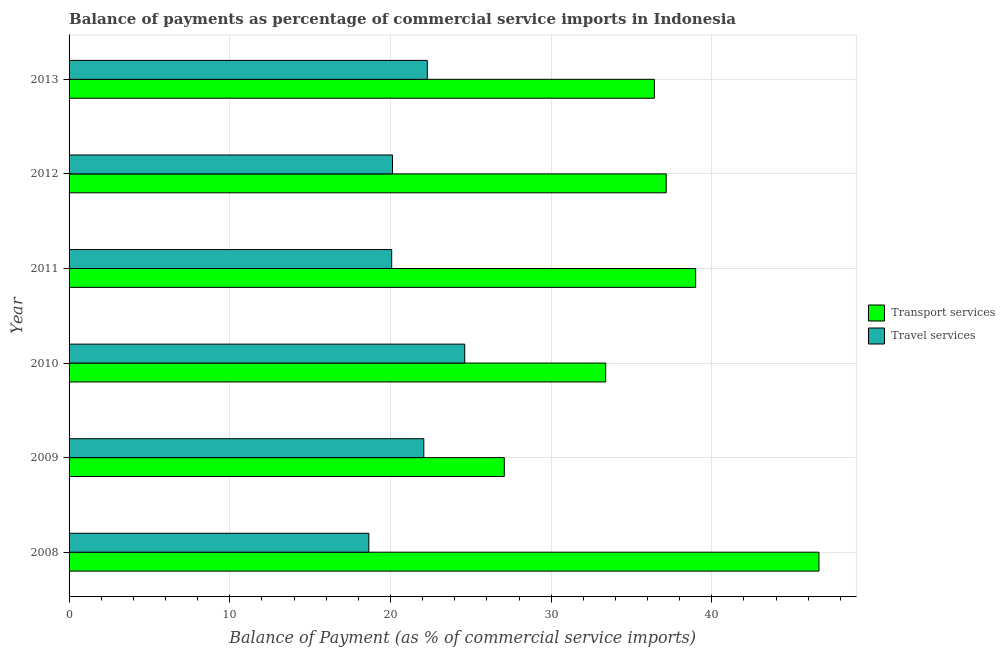In how many cases, is the number of bars for a given year not equal to the number of legend labels?
Keep it short and to the point. 0. What is the balance of payments of transport services in 2010?
Offer a terse response. 33.39. Across all years, what is the maximum balance of payments of transport services?
Ensure brevity in your answer.  46.67. Across all years, what is the minimum balance of payments of travel services?
Your answer should be very brief. 18.65. In which year was the balance of payments of travel services maximum?
Your answer should be compact. 2010. In which year was the balance of payments of travel services minimum?
Your answer should be very brief. 2008. What is the total balance of payments of travel services in the graph?
Give a very brief answer. 127.85. What is the difference between the balance of payments of travel services in 2008 and that in 2012?
Make the answer very short. -1.47. What is the difference between the balance of payments of transport services in 2011 and the balance of payments of travel services in 2009?
Ensure brevity in your answer.  16.92. What is the average balance of payments of transport services per year?
Offer a very short reply. 36.62. In the year 2012, what is the difference between the balance of payments of travel services and balance of payments of transport services?
Offer a very short reply. -17.04. In how many years, is the balance of payments of travel services greater than 14 %?
Give a very brief answer. 6. What is the ratio of the balance of payments of transport services in 2010 to that in 2013?
Your answer should be very brief. 0.92. Is the balance of payments of travel services in 2008 less than that in 2011?
Keep it short and to the point. Yes. What is the difference between the highest and the second highest balance of payments of travel services?
Your answer should be very brief. 2.33. What is the difference between the highest and the lowest balance of payments of travel services?
Your response must be concise. 5.97. Is the sum of the balance of payments of transport services in 2010 and 2011 greater than the maximum balance of payments of travel services across all years?
Offer a terse response. Yes. What does the 1st bar from the top in 2010 represents?
Give a very brief answer. Travel services. What does the 2nd bar from the bottom in 2013 represents?
Provide a succinct answer. Travel services. How many bars are there?
Keep it short and to the point. 12. What is the difference between two consecutive major ticks on the X-axis?
Keep it short and to the point. 10. Are the values on the major ticks of X-axis written in scientific E-notation?
Ensure brevity in your answer.  No. What is the title of the graph?
Your answer should be very brief. Balance of payments as percentage of commercial service imports in Indonesia. What is the label or title of the X-axis?
Your answer should be very brief. Balance of Payment (as % of commercial service imports). What is the Balance of Payment (as % of commercial service imports) in Transport services in 2008?
Provide a succinct answer. 46.67. What is the Balance of Payment (as % of commercial service imports) in Travel services in 2008?
Provide a succinct answer. 18.65. What is the Balance of Payment (as % of commercial service imports) of Transport services in 2009?
Make the answer very short. 27.08. What is the Balance of Payment (as % of commercial service imports) in Travel services in 2009?
Keep it short and to the point. 22.08. What is the Balance of Payment (as % of commercial service imports) of Transport services in 2010?
Provide a succinct answer. 33.39. What is the Balance of Payment (as % of commercial service imports) of Travel services in 2010?
Offer a terse response. 24.62. What is the Balance of Payment (as % of commercial service imports) in Transport services in 2011?
Your response must be concise. 38.99. What is the Balance of Payment (as % of commercial service imports) of Travel services in 2011?
Offer a very short reply. 20.08. What is the Balance of Payment (as % of commercial service imports) in Transport services in 2012?
Your answer should be compact. 37.16. What is the Balance of Payment (as % of commercial service imports) of Travel services in 2012?
Make the answer very short. 20.13. What is the Balance of Payment (as % of commercial service imports) in Transport services in 2013?
Your answer should be compact. 36.42. What is the Balance of Payment (as % of commercial service imports) in Travel services in 2013?
Your answer should be very brief. 22.29. Across all years, what is the maximum Balance of Payment (as % of commercial service imports) of Transport services?
Make the answer very short. 46.67. Across all years, what is the maximum Balance of Payment (as % of commercial service imports) in Travel services?
Your response must be concise. 24.62. Across all years, what is the minimum Balance of Payment (as % of commercial service imports) of Transport services?
Your answer should be compact. 27.08. Across all years, what is the minimum Balance of Payment (as % of commercial service imports) in Travel services?
Give a very brief answer. 18.65. What is the total Balance of Payment (as % of commercial service imports) of Transport services in the graph?
Provide a succinct answer. 219.72. What is the total Balance of Payment (as % of commercial service imports) in Travel services in the graph?
Make the answer very short. 127.85. What is the difference between the Balance of Payment (as % of commercial service imports) in Transport services in 2008 and that in 2009?
Your answer should be compact. 19.58. What is the difference between the Balance of Payment (as % of commercial service imports) of Travel services in 2008 and that in 2009?
Your response must be concise. -3.42. What is the difference between the Balance of Payment (as % of commercial service imports) in Transport services in 2008 and that in 2010?
Give a very brief answer. 13.27. What is the difference between the Balance of Payment (as % of commercial service imports) of Travel services in 2008 and that in 2010?
Keep it short and to the point. -5.97. What is the difference between the Balance of Payment (as % of commercial service imports) in Transport services in 2008 and that in 2011?
Make the answer very short. 7.67. What is the difference between the Balance of Payment (as % of commercial service imports) of Travel services in 2008 and that in 2011?
Ensure brevity in your answer.  -1.42. What is the difference between the Balance of Payment (as % of commercial service imports) in Transport services in 2008 and that in 2012?
Make the answer very short. 9.5. What is the difference between the Balance of Payment (as % of commercial service imports) of Travel services in 2008 and that in 2012?
Your answer should be compact. -1.47. What is the difference between the Balance of Payment (as % of commercial service imports) of Transport services in 2008 and that in 2013?
Ensure brevity in your answer.  10.24. What is the difference between the Balance of Payment (as % of commercial service imports) of Travel services in 2008 and that in 2013?
Offer a very short reply. -3.64. What is the difference between the Balance of Payment (as % of commercial service imports) of Transport services in 2009 and that in 2010?
Your answer should be compact. -6.31. What is the difference between the Balance of Payment (as % of commercial service imports) in Travel services in 2009 and that in 2010?
Your answer should be very brief. -2.55. What is the difference between the Balance of Payment (as % of commercial service imports) of Transport services in 2009 and that in 2011?
Keep it short and to the point. -11.91. What is the difference between the Balance of Payment (as % of commercial service imports) in Travel services in 2009 and that in 2011?
Provide a succinct answer. 2. What is the difference between the Balance of Payment (as % of commercial service imports) of Transport services in 2009 and that in 2012?
Provide a short and direct response. -10.08. What is the difference between the Balance of Payment (as % of commercial service imports) in Travel services in 2009 and that in 2012?
Provide a short and direct response. 1.95. What is the difference between the Balance of Payment (as % of commercial service imports) in Transport services in 2009 and that in 2013?
Ensure brevity in your answer.  -9.34. What is the difference between the Balance of Payment (as % of commercial service imports) in Travel services in 2009 and that in 2013?
Your response must be concise. -0.22. What is the difference between the Balance of Payment (as % of commercial service imports) in Transport services in 2010 and that in 2011?
Provide a short and direct response. -5.6. What is the difference between the Balance of Payment (as % of commercial service imports) in Travel services in 2010 and that in 2011?
Give a very brief answer. 4.54. What is the difference between the Balance of Payment (as % of commercial service imports) in Transport services in 2010 and that in 2012?
Offer a terse response. -3.77. What is the difference between the Balance of Payment (as % of commercial service imports) of Travel services in 2010 and that in 2012?
Offer a terse response. 4.49. What is the difference between the Balance of Payment (as % of commercial service imports) in Transport services in 2010 and that in 2013?
Give a very brief answer. -3.03. What is the difference between the Balance of Payment (as % of commercial service imports) of Travel services in 2010 and that in 2013?
Offer a terse response. 2.33. What is the difference between the Balance of Payment (as % of commercial service imports) of Transport services in 2011 and that in 2012?
Ensure brevity in your answer.  1.83. What is the difference between the Balance of Payment (as % of commercial service imports) in Travel services in 2011 and that in 2012?
Provide a succinct answer. -0.05. What is the difference between the Balance of Payment (as % of commercial service imports) in Transport services in 2011 and that in 2013?
Your answer should be very brief. 2.57. What is the difference between the Balance of Payment (as % of commercial service imports) in Travel services in 2011 and that in 2013?
Make the answer very short. -2.22. What is the difference between the Balance of Payment (as % of commercial service imports) in Transport services in 2012 and that in 2013?
Offer a terse response. 0.74. What is the difference between the Balance of Payment (as % of commercial service imports) of Travel services in 2012 and that in 2013?
Your answer should be very brief. -2.17. What is the difference between the Balance of Payment (as % of commercial service imports) of Transport services in 2008 and the Balance of Payment (as % of commercial service imports) of Travel services in 2009?
Ensure brevity in your answer.  24.59. What is the difference between the Balance of Payment (as % of commercial service imports) of Transport services in 2008 and the Balance of Payment (as % of commercial service imports) of Travel services in 2010?
Offer a terse response. 22.04. What is the difference between the Balance of Payment (as % of commercial service imports) of Transport services in 2008 and the Balance of Payment (as % of commercial service imports) of Travel services in 2011?
Provide a short and direct response. 26.59. What is the difference between the Balance of Payment (as % of commercial service imports) of Transport services in 2008 and the Balance of Payment (as % of commercial service imports) of Travel services in 2012?
Keep it short and to the point. 26.54. What is the difference between the Balance of Payment (as % of commercial service imports) in Transport services in 2008 and the Balance of Payment (as % of commercial service imports) in Travel services in 2013?
Offer a terse response. 24.37. What is the difference between the Balance of Payment (as % of commercial service imports) in Transport services in 2009 and the Balance of Payment (as % of commercial service imports) in Travel services in 2010?
Provide a short and direct response. 2.46. What is the difference between the Balance of Payment (as % of commercial service imports) of Transport services in 2009 and the Balance of Payment (as % of commercial service imports) of Travel services in 2011?
Make the answer very short. 7.01. What is the difference between the Balance of Payment (as % of commercial service imports) in Transport services in 2009 and the Balance of Payment (as % of commercial service imports) in Travel services in 2012?
Your response must be concise. 6.96. What is the difference between the Balance of Payment (as % of commercial service imports) of Transport services in 2009 and the Balance of Payment (as % of commercial service imports) of Travel services in 2013?
Offer a very short reply. 4.79. What is the difference between the Balance of Payment (as % of commercial service imports) in Transport services in 2010 and the Balance of Payment (as % of commercial service imports) in Travel services in 2011?
Give a very brief answer. 13.32. What is the difference between the Balance of Payment (as % of commercial service imports) of Transport services in 2010 and the Balance of Payment (as % of commercial service imports) of Travel services in 2012?
Provide a short and direct response. 13.27. What is the difference between the Balance of Payment (as % of commercial service imports) of Transport services in 2010 and the Balance of Payment (as % of commercial service imports) of Travel services in 2013?
Make the answer very short. 11.1. What is the difference between the Balance of Payment (as % of commercial service imports) of Transport services in 2011 and the Balance of Payment (as % of commercial service imports) of Travel services in 2012?
Your answer should be compact. 18.87. What is the difference between the Balance of Payment (as % of commercial service imports) of Transport services in 2011 and the Balance of Payment (as % of commercial service imports) of Travel services in 2013?
Your response must be concise. 16.7. What is the difference between the Balance of Payment (as % of commercial service imports) in Transport services in 2012 and the Balance of Payment (as % of commercial service imports) in Travel services in 2013?
Make the answer very short. 14.87. What is the average Balance of Payment (as % of commercial service imports) of Transport services per year?
Provide a succinct answer. 36.62. What is the average Balance of Payment (as % of commercial service imports) in Travel services per year?
Give a very brief answer. 21.31. In the year 2008, what is the difference between the Balance of Payment (as % of commercial service imports) in Transport services and Balance of Payment (as % of commercial service imports) in Travel services?
Your answer should be compact. 28.01. In the year 2009, what is the difference between the Balance of Payment (as % of commercial service imports) of Transport services and Balance of Payment (as % of commercial service imports) of Travel services?
Keep it short and to the point. 5.01. In the year 2010, what is the difference between the Balance of Payment (as % of commercial service imports) in Transport services and Balance of Payment (as % of commercial service imports) in Travel services?
Your response must be concise. 8.77. In the year 2011, what is the difference between the Balance of Payment (as % of commercial service imports) of Transport services and Balance of Payment (as % of commercial service imports) of Travel services?
Provide a short and direct response. 18.92. In the year 2012, what is the difference between the Balance of Payment (as % of commercial service imports) of Transport services and Balance of Payment (as % of commercial service imports) of Travel services?
Your answer should be very brief. 17.04. In the year 2013, what is the difference between the Balance of Payment (as % of commercial service imports) in Transport services and Balance of Payment (as % of commercial service imports) in Travel services?
Give a very brief answer. 14.13. What is the ratio of the Balance of Payment (as % of commercial service imports) of Transport services in 2008 to that in 2009?
Provide a succinct answer. 1.72. What is the ratio of the Balance of Payment (as % of commercial service imports) of Travel services in 2008 to that in 2009?
Your answer should be compact. 0.84. What is the ratio of the Balance of Payment (as % of commercial service imports) in Transport services in 2008 to that in 2010?
Give a very brief answer. 1.4. What is the ratio of the Balance of Payment (as % of commercial service imports) of Travel services in 2008 to that in 2010?
Provide a short and direct response. 0.76. What is the ratio of the Balance of Payment (as % of commercial service imports) in Transport services in 2008 to that in 2011?
Ensure brevity in your answer.  1.2. What is the ratio of the Balance of Payment (as % of commercial service imports) of Travel services in 2008 to that in 2011?
Offer a terse response. 0.93. What is the ratio of the Balance of Payment (as % of commercial service imports) of Transport services in 2008 to that in 2012?
Offer a terse response. 1.26. What is the ratio of the Balance of Payment (as % of commercial service imports) in Travel services in 2008 to that in 2012?
Ensure brevity in your answer.  0.93. What is the ratio of the Balance of Payment (as % of commercial service imports) in Transport services in 2008 to that in 2013?
Offer a very short reply. 1.28. What is the ratio of the Balance of Payment (as % of commercial service imports) in Travel services in 2008 to that in 2013?
Give a very brief answer. 0.84. What is the ratio of the Balance of Payment (as % of commercial service imports) in Transport services in 2009 to that in 2010?
Make the answer very short. 0.81. What is the ratio of the Balance of Payment (as % of commercial service imports) in Travel services in 2009 to that in 2010?
Give a very brief answer. 0.9. What is the ratio of the Balance of Payment (as % of commercial service imports) of Transport services in 2009 to that in 2011?
Give a very brief answer. 0.69. What is the ratio of the Balance of Payment (as % of commercial service imports) of Travel services in 2009 to that in 2011?
Your response must be concise. 1.1. What is the ratio of the Balance of Payment (as % of commercial service imports) in Transport services in 2009 to that in 2012?
Provide a short and direct response. 0.73. What is the ratio of the Balance of Payment (as % of commercial service imports) of Travel services in 2009 to that in 2012?
Keep it short and to the point. 1.1. What is the ratio of the Balance of Payment (as % of commercial service imports) of Transport services in 2009 to that in 2013?
Give a very brief answer. 0.74. What is the ratio of the Balance of Payment (as % of commercial service imports) in Travel services in 2009 to that in 2013?
Your answer should be very brief. 0.99. What is the ratio of the Balance of Payment (as % of commercial service imports) in Transport services in 2010 to that in 2011?
Provide a succinct answer. 0.86. What is the ratio of the Balance of Payment (as % of commercial service imports) in Travel services in 2010 to that in 2011?
Offer a terse response. 1.23. What is the ratio of the Balance of Payment (as % of commercial service imports) in Transport services in 2010 to that in 2012?
Provide a short and direct response. 0.9. What is the ratio of the Balance of Payment (as % of commercial service imports) in Travel services in 2010 to that in 2012?
Ensure brevity in your answer.  1.22. What is the ratio of the Balance of Payment (as % of commercial service imports) in Transport services in 2010 to that in 2013?
Offer a terse response. 0.92. What is the ratio of the Balance of Payment (as % of commercial service imports) of Travel services in 2010 to that in 2013?
Provide a succinct answer. 1.1. What is the ratio of the Balance of Payment (as % of commercial service imports) of Transport services in 2011 to that in 2012?
Provide a succinct answer. 1.05. What is the ratio of the Balance of Payment (as % of commercial service imports) in Travel services in 2011 to that in 2012?
Ensure brevity in your answer.  1. What is the ratio of the Balance of Payment (as % of commercial service imports) of Transport services in 2011 to that in 2013?
Ensure brevity in your answer.  1.07. What is the ratio of the Balance of Payment (as % of commercial service imports) in Travel services in 2011 to that in 2013?
Make the answer very short. 0.9. What is the ratio of the Balance of Payment (as % of commercial service imports) of Transport services in 2012 to that in 2013?
Keep it short and to the point. 1.02. What is the ratio of the Balance of Payment (as % of commercial service imports) in Travel services in 2012 to that in 2013?
Keep it short and to the point. 0.9. What is the difference between the highest and the second highest Balance of Payment (as % of commercial service imports) of Transport services?
Ensure brevity in your answer.  7.67. What is the difference between the highest and the second highest Balance of Payment (as % of commercial service imports) in Travel services?
Provide a short and direct response. 2.33. What is the difference between the highest and the lowest Balance of Payment (as % of commercial service imports) in Transport services?
Provide a short and direct response. 19.58. What is the difference between the highest and the lowest Balance of Payment (as % of commercial service imports) in Travel services?
Provide a succinct answer. 5.97. 